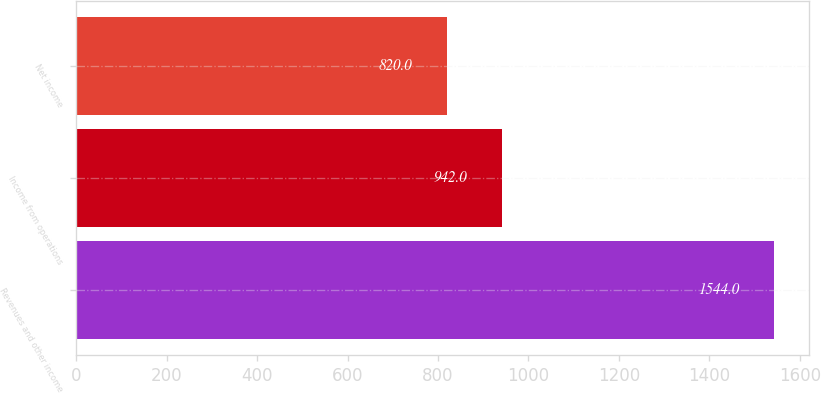Convert chart. <chart><loc_0><loc_0><loc_500><loc_500><bar_chart><fcel>Revenues and other income<fcel>Income from operations<fcel>Net income<nl><fcel>1544<fcel>942<fcel>820<nl></chart> 